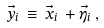<formula> <loc_0><loc_0><loc_500><loc_500>\vec { y } _ { i } \, \equiv \, \vec { x } _ { i } \, + \vec { \eta } _ { i } \, ,</formula> 